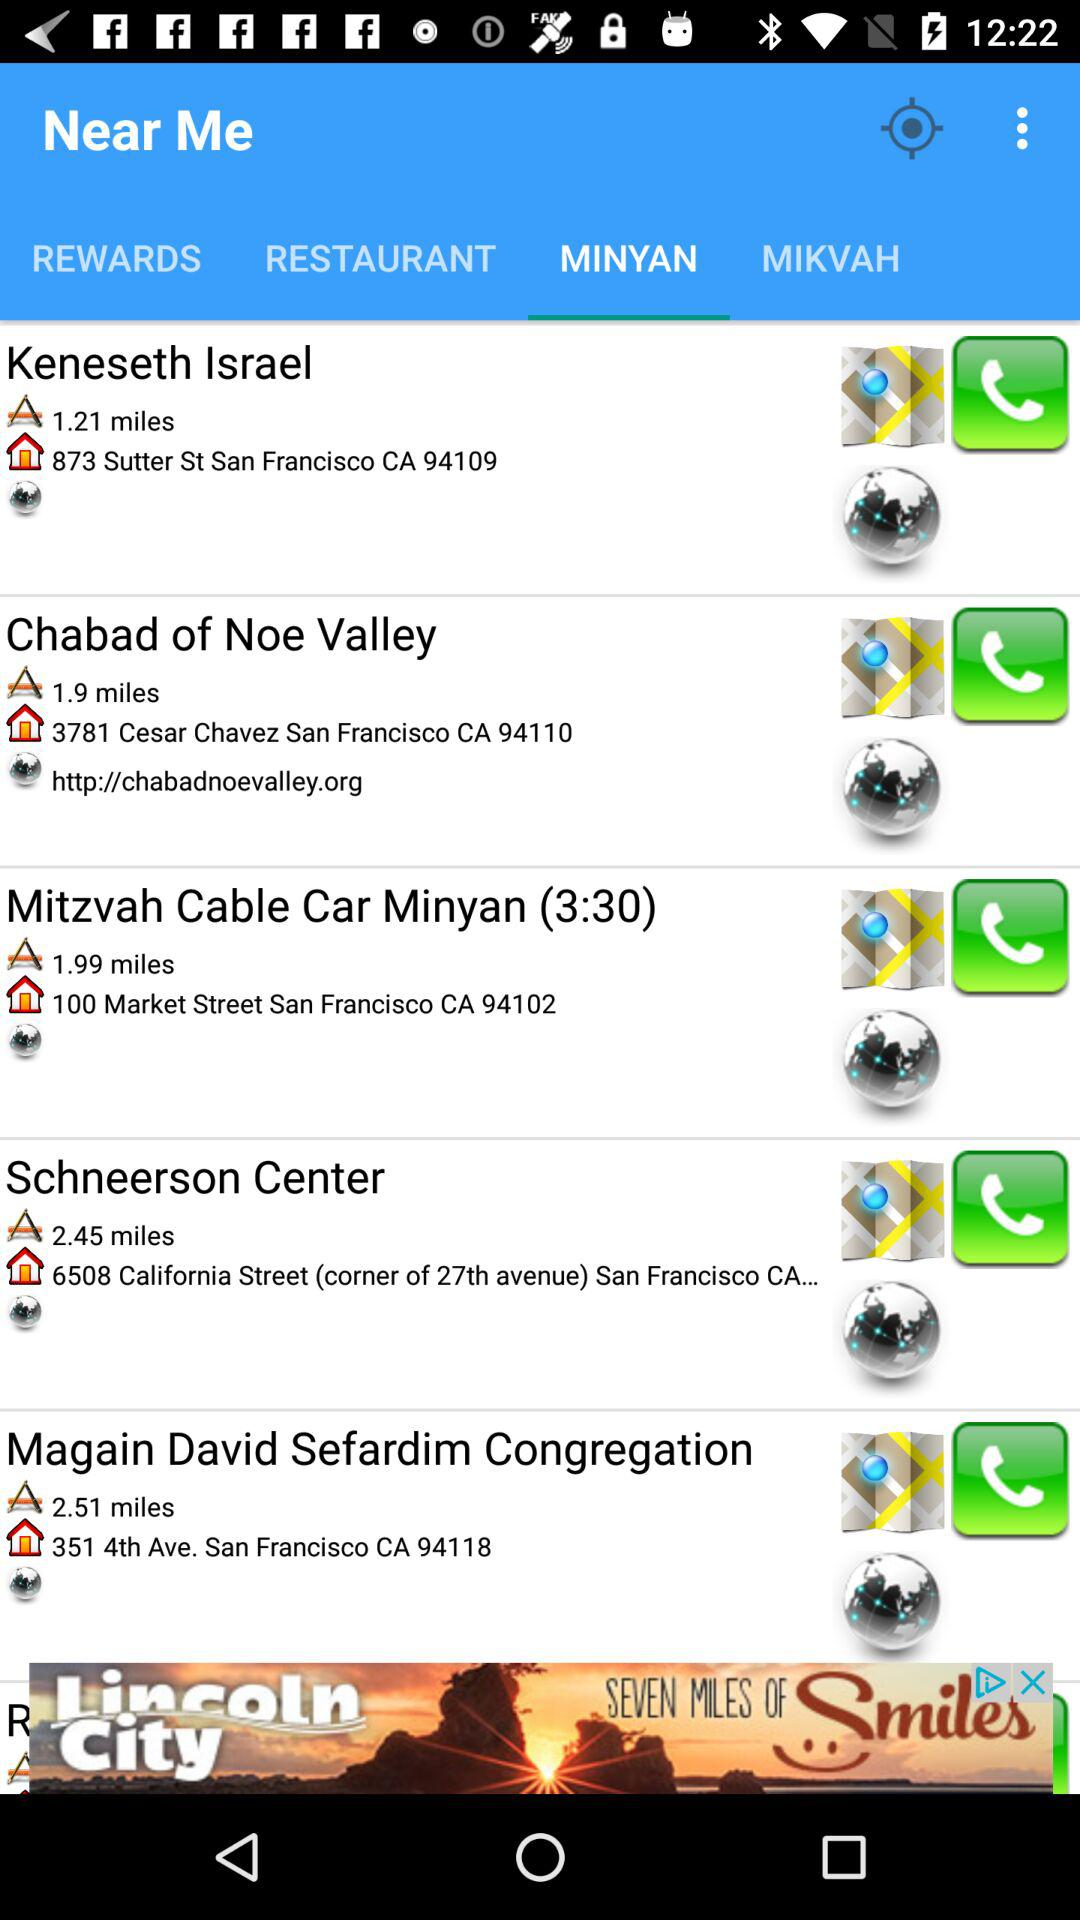Which tab am I on? You are on "MINYAN" tab. 